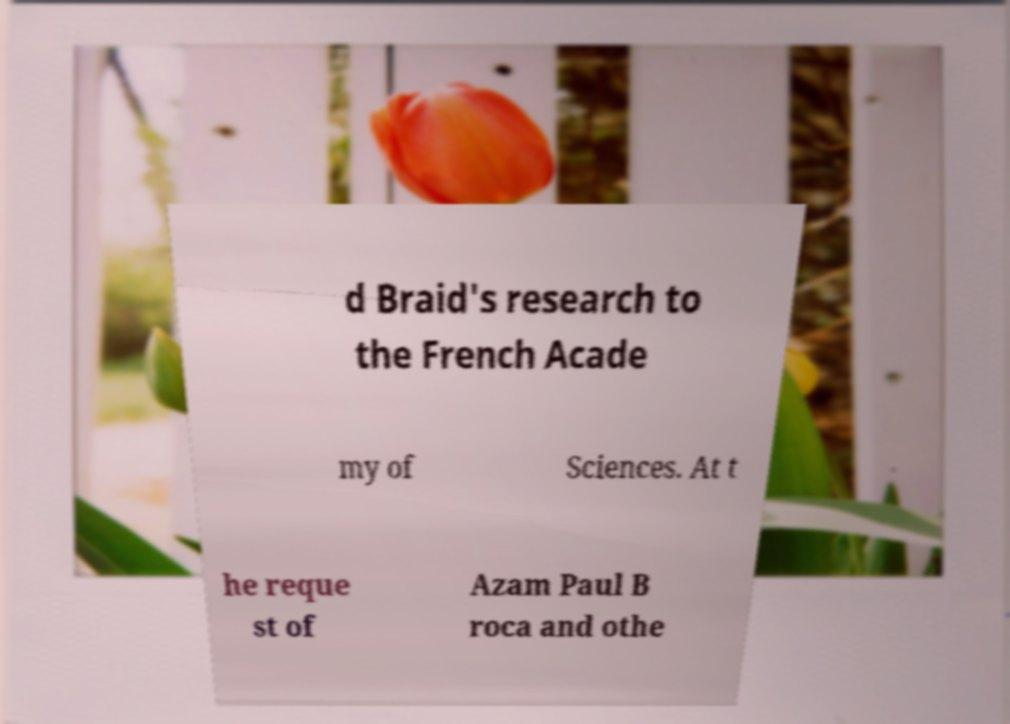Could you extract and type out the text from this image? d Braid's research to the French Acade my of Sciences. At t he reque st of Azam Paul B roca and othe 